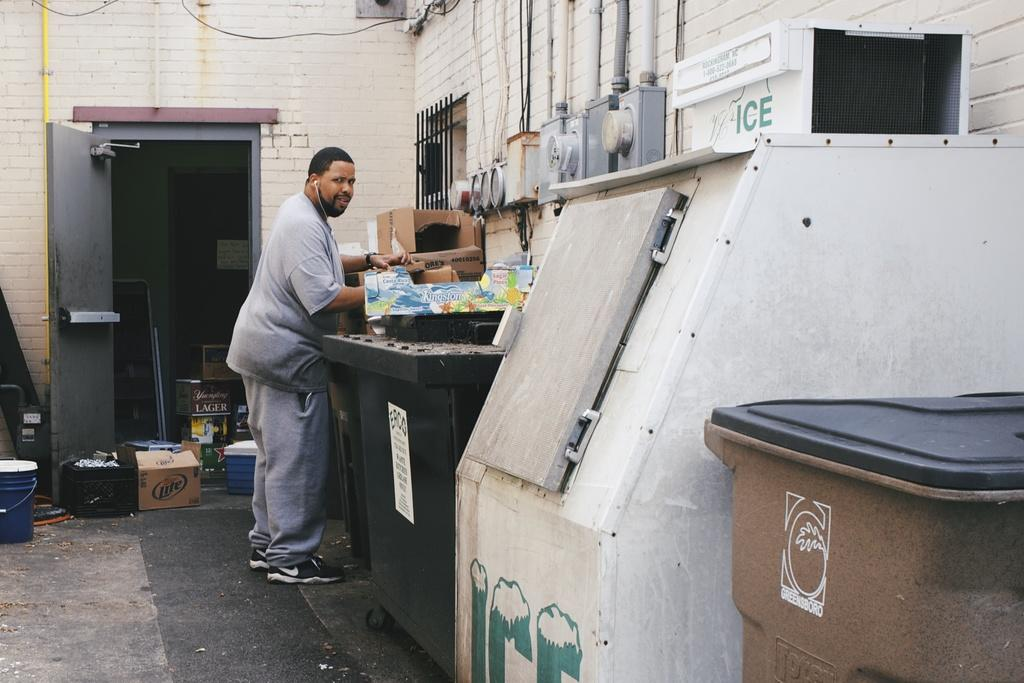<image>
Present a compact description of the photo's key features. White container with green letters that say ICE. 